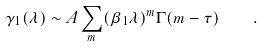Convert formula to latex. <formula><loc_0><loc_0><loc_500><loc_500>\gamma _ { 1 } ( \lambda ) \sim A \sum _ { m } ( \beta _ { 1 } \lambda ) ^ { m } \Gamma ( m - \tau ) \quad .</formula> 